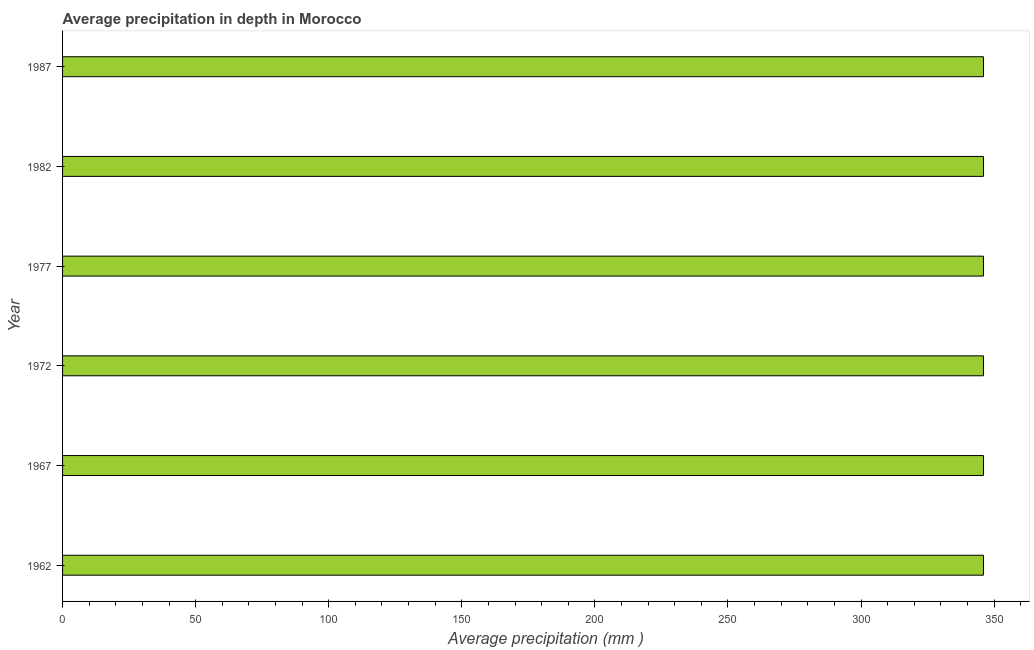What is the title of the graph?
Your response must be concise. Average precipitation in depth in Morocco. What is the label or title of the X-axis?
Provide a succinct answer. Average precipitation (mm ). What is the average precipitation in depth in 1962?
Your response must be concise. 346. Across all years, what is the maximum average precipitation in depth?
Your response must be concise. 346. Across all years, what is the minimum average precipitation in depth?
Your answer should be very brief. 346. In which year was the average precipitation in depth maximum?
Your answer should be very brief. 1962. In which year was the average precipitation in depth minimum?
Give a very brief answer. 1962. What is the sum of the average precipitation in depth?
Provide a short and direct response. 2076. What is the average average precipitation in depth per year?
Make the answer very short. 346. What is the median average precipitation in depth?
Make the answer very short. 346. In how many years, is the average precipitation in depth greater than 150 mm?
Provide a succinct answer. 6. What is the ratio of the average precipitation in depth in 1972 to that in 1982?
Make the answer very short. 1. Is the sum of the average precipitation in depth in 1967 and 1977 greater than the maximum average precipitation in depth across all years?
Your answer should be compact. Yes. What is the difference between the highest and the lowest average precipitation in depth?
Offer a very short reply. 0. What is the difference between two consecutive major ticks on the X-axis?
Your response must be concise. 50. What is the Average precipitation (mm ) in 1962?
Provide a succinct answer. 346. What is the Average precipitation (mm ) in 1967?
Your answer should be compact. 346. What is the Average precipitation (mm ) of 1972?
Ensure brevity in your answer.  346. What is the Average precipitation (mm ) of 1977?
Offer a very short reply. 346. What is the Average precipitation (mm ) of 1982?
Your answer should be very brief. 346. What is the Average precipitation (mm ) in 1987?
Give a very brief answer. 346. What is the difference between the Average precipitation (mm ) in 1962 and 1967?
Your response must be concise. 0. What is the difference between the Average precipitation (mm ) in 1962 and 1982?
Offer a terse response. 0. What is the difference between the Average precipitation (mm ) in 1967 and 1972?
Provide a succinct answer. 0. What is the difference between the Average precipitation (mm ) in 1972 and 1987?
Give a very brief answer. 0. What is the difference between the Average precipitation (mm ) in 1977 and 1987?
Provide a short and direct response. 0. What is the difference between the Average precipitation (mm ) in 1982 and 1987?
Your answer should be very brief. 0. What is the ratio of the Average precipitation (mm ) in 1962 to that in 1972?
Give a very brief answer. 1. What is the ratio of the Average precipitation (mm ) in 1962 to that in 1987?
Give a very brief answer. 1. What is the ratio of the Average precipitation (mm ) in 1967 to that in 1982?
Keep it short and to the point. 1. What is the ratio of the Average precipitation (mm ) in 1967 to that in 1987?
Ensure brevity in your answer.  1. What is the ratio of the Average precipitation (mm ) in 1972 to that in 1977?
Offer a very short reply. 1. What is the ratio of the Average precipitation (mm ) in 1972 to that in 1982?
Give a very brief answer. 1. What is the ratio of the Average precipitation (mm ) in 1977 to that in 1982?
Make the answer very short. 1. What is the ratio of the Average precipitation (mm ) in 1977 to that in 1987?
Offer a very short reply. 1. What is the ratio of the Average precipitation (mm ) in 1982 to that in 1987?
Provide a short and direct response. 1. 